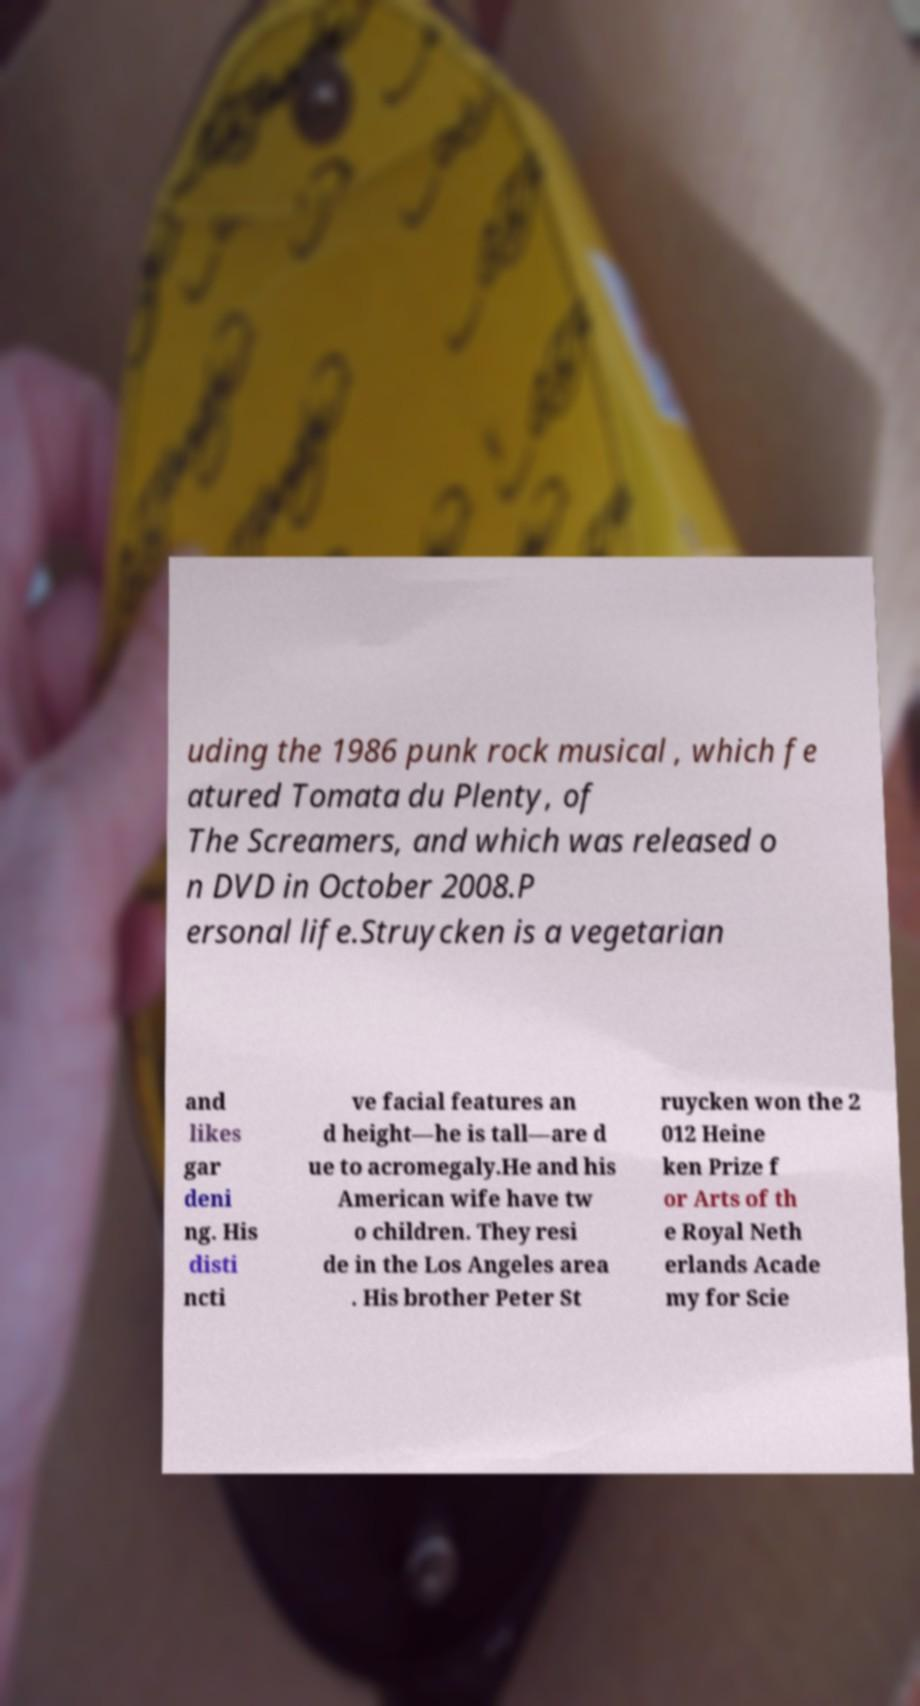For documentation purposes, I need the text within this image transcribed. Could you provide that? uding the 1986 punk rock musical , which fe atured Tomata du Plenty, of The Screamers, and which was released o n DVD in October 2008.P ersonal life.Struycken is a vegetarian and likes gar deni ng. His disti ncti ve facial features an d height—he is tall—are d ue to acromegaly.He and his American wife have tw o children. They resi de in the Los Angeles area . His brother Peter St ruycken won the 2 012 Heine ken Prize f or Arts of th e Royal Neth erlands Acade my for Scie 